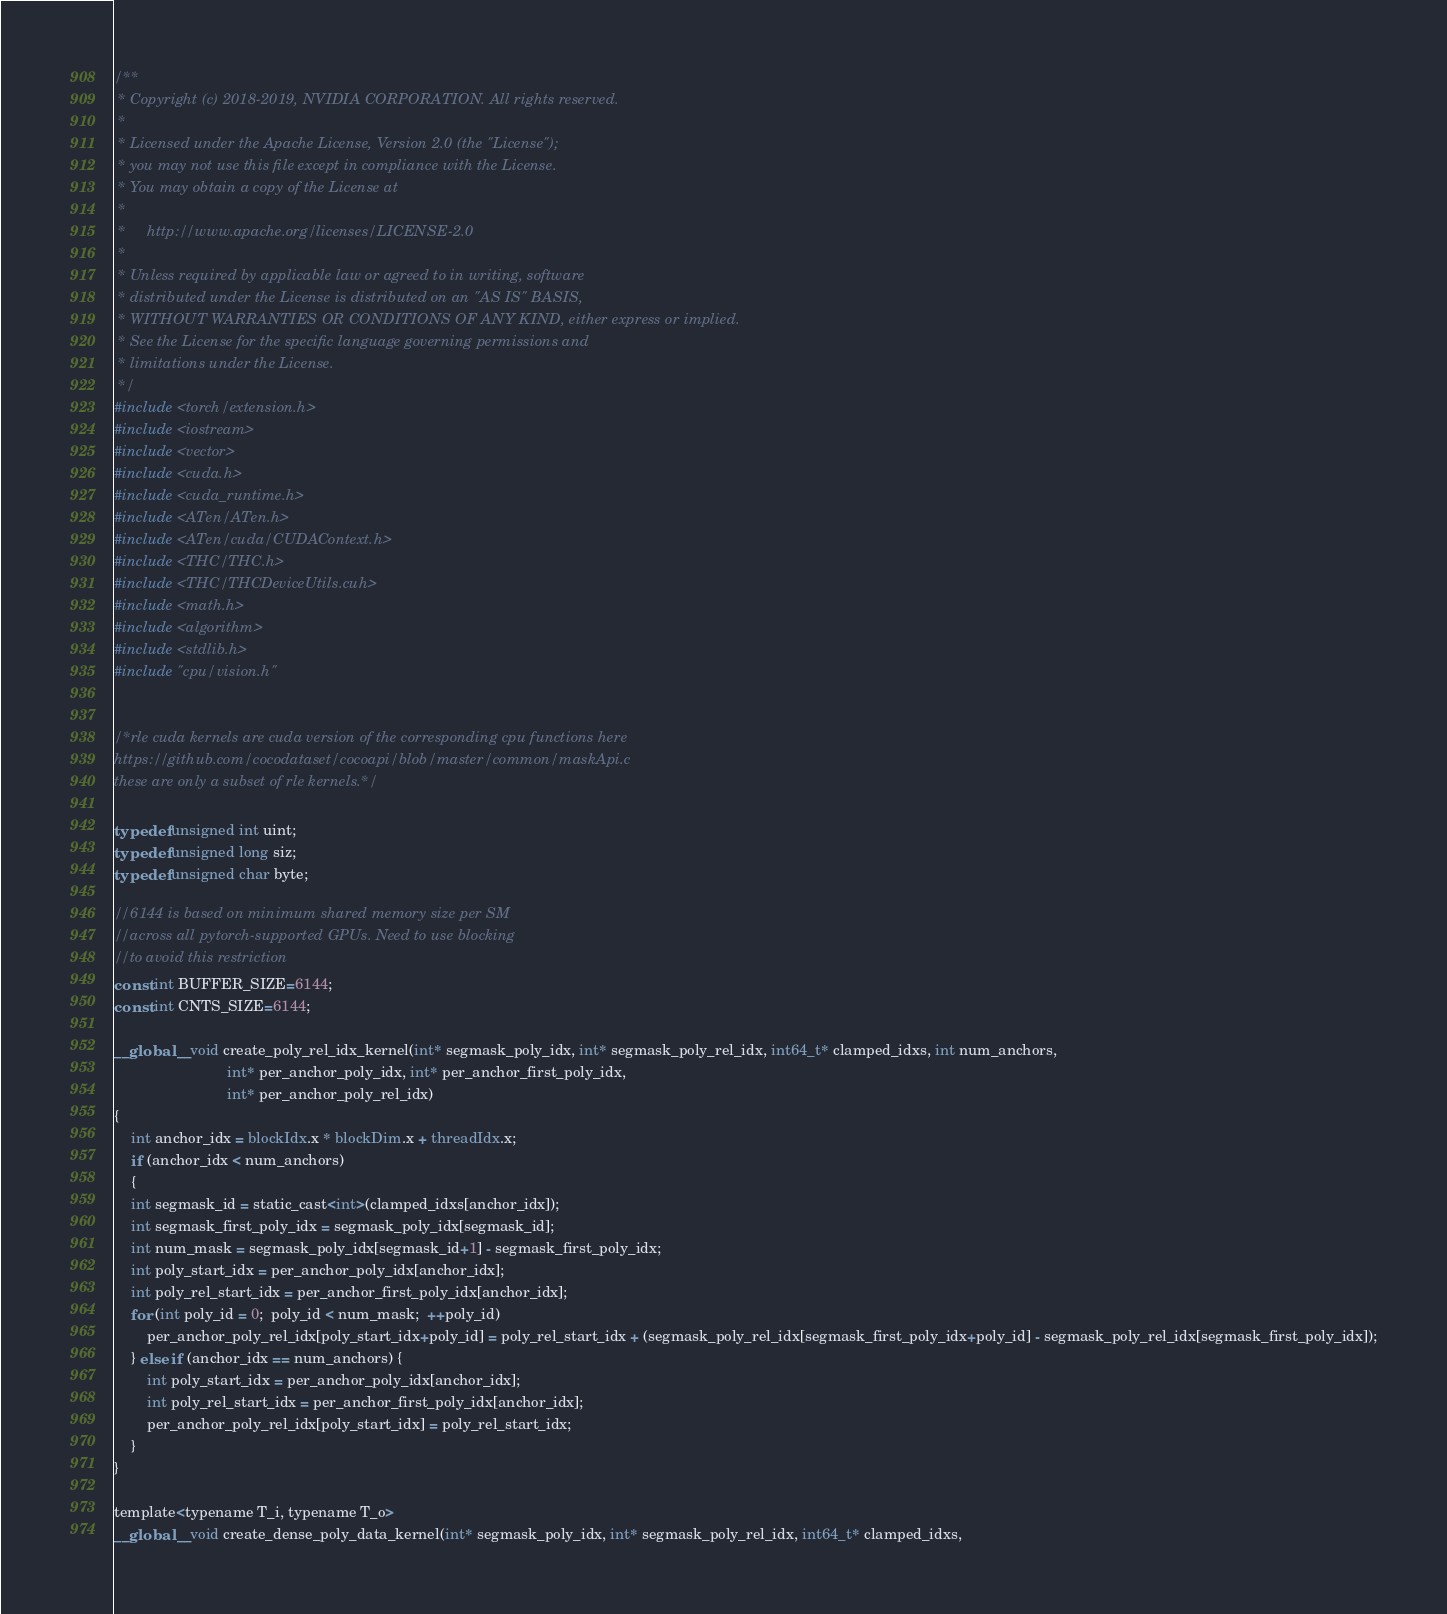Convert code to text. <code><loc_0><loc_0><loc_500><loc_500><_Cuda_>/**
 * Copyright (c) 2018-2019, NVIDIA CORPORATION. All rights reserved.
 *
 * Licensed under the Apache License, Version 2.0 (the "License");
 * you may not use this file except in compliance with the License.
 * You may obtain a copy of the License at
 *
 *     http://www.apache.org/licenses/LICENSE-2.0
 *
 * Unless required by applicable law or agreed to in writing, software
 * distributed under the License is distributed on an "AS IS" BASIS,
 * WITHOUT WARRANTIES OR CONDITIONS OF ANY KIND, either express or implied.
 * See the License for the specific language governing permissions and
 * limitations under the License.
 */
#include <torch/extension.h>
#include <iostream>
#include <vector>
#include <cuda.h>
#include <cuda_runtime.h>
#include <ATen/ATen.h>
#include <ATen/cuda/CUDAContext.h>
#include <THC/THC.h>
#include <THC/THCDeviceUtils.cuh>
#include <math.h>
#include <algorithm>
#include <stdlib.h>
#include "cpu/vision.h"


/*rle cuda kernels are cuda version of the corresponding cpu functions here 
https://github.com/cocodataset/cocoapi/blob/master/common/maskApi.c 
these are only a subset of rle kernels.*/

typedef unsigned int uint;
typedef unsigned long siz;
typedef unsigned char byte;

//6144 is based on minimum shared memory size per SM 
//across all pytorch-supported GPUs. Need to use blocking
//to avoid this restriction
const int BUFFER_SIZE=6144;
const int CNTS_SIZE=6144;

__global__ void create_poly_rel_idx_kernel(int* segmask_poly_idx, int* segmask_poly_rel_idx, int64_t* clamped_idxs, int num_anchors,
				           int* per_anchor_poly_idx, int* per_anchor_first_poly_idx,
				           int* per_anchor_poly_rel_idx)
{
    int anchor_idx = blockIdx.x * blockDim.x + threadIdx.x;
    if (anchor_idx < num_anchors)
    {
	int segmask_id = static_cast<int>(clamped_idxs[anchor_idx]);
	int segmask_first_poly_idx = segmask_poly_idx[segmask_id];
	int num_mask = segmask_poly_idx[segmask_id+1] - segmask_first_poly_idx;
	int poly_start_idx = per_anchor_poly_idx[anchor_idx];
	int poly_rel_start_idx = per_anchor_first_poly_idx[anchor_idx];
	for (int poly_id = 0;  poly_id < num_mask;  ++poly_id)
	    per_anchor_poly_rel_idx[poly_start_idx+poly_id] = poly_rel_start_idx + (segmask_poly_rel_idx[segmask_first_poly_idx+poly_id] - segmask_poly_rel_idx[segmask_first_poly_idx]);
    } else if (anchor_idx == num_anchors) {
        int poly_start_idx = per_anchor_poly_idx[anchor_idx];
        int poly_rel_start_idx = per_anchor_first_poly_idx[anchor_idx];
        per_anchor_poly_rel_idx[poly_start_idx] = poly_rel_start_idx;
    }
}

template<typename T_i, typename T_o>
__global__ void create_dense_poly_data_kernel(int* segmask_poly_idx, int* segmask_poly_rel_idx, int64_t* clamped_idxs,</code> 